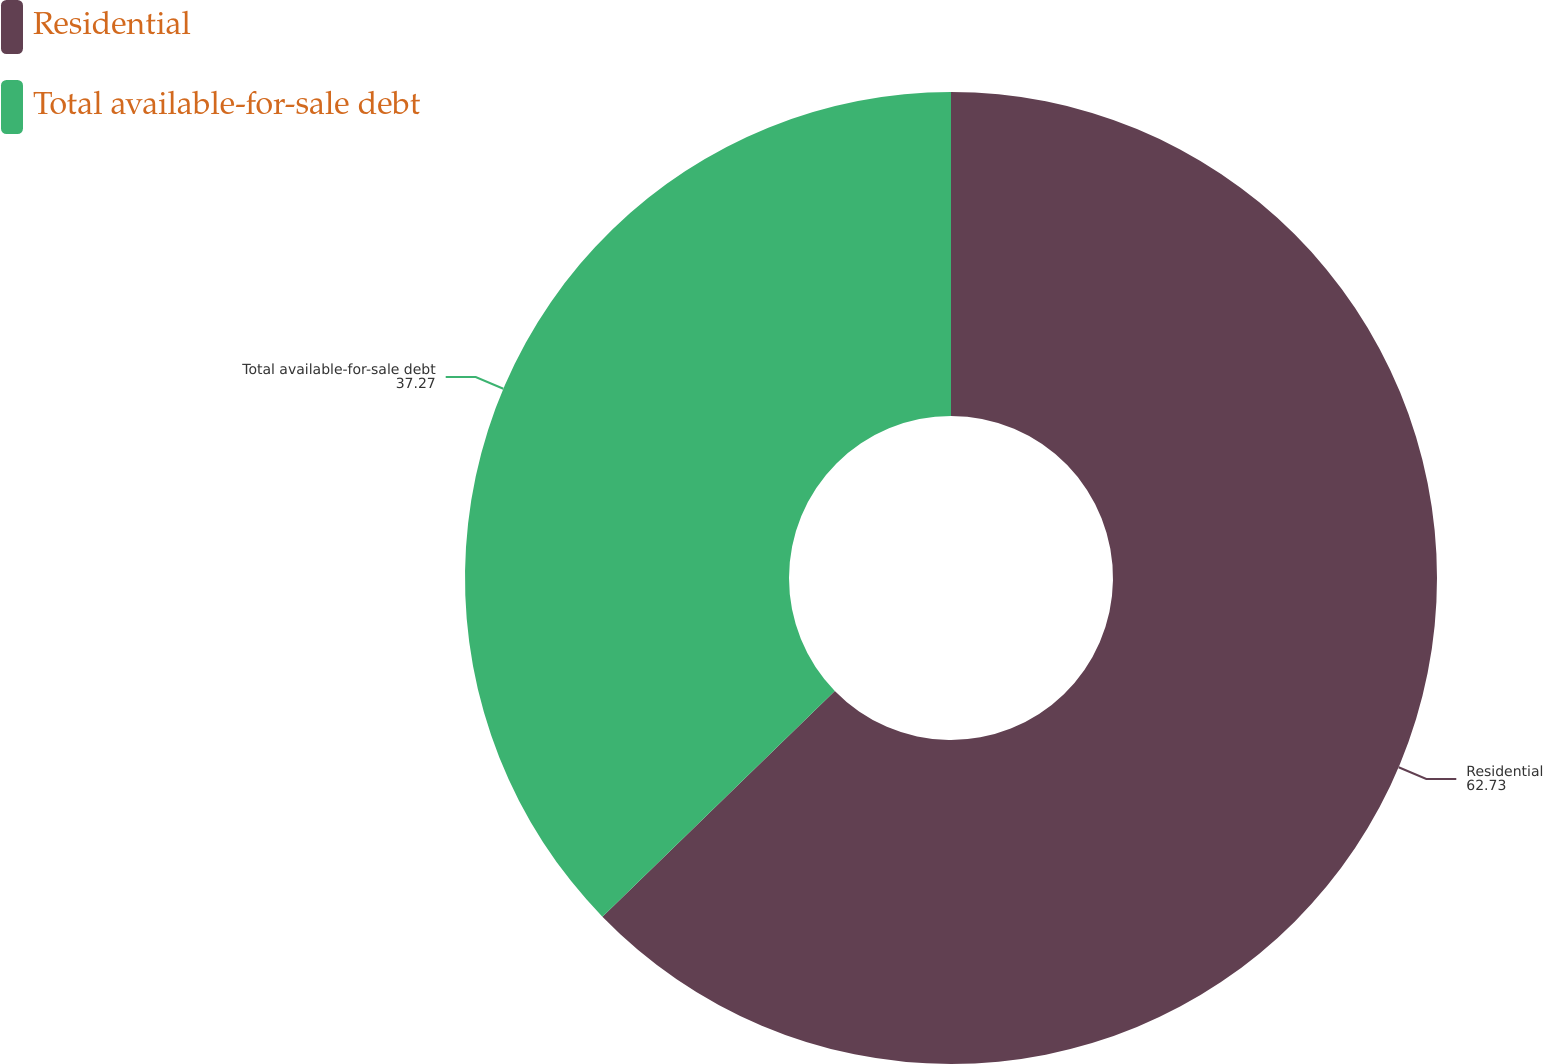Convert chart to OTSL. <chart><loc_0><loc_0><loc_500><loc_500><pie_chart><fcel>Residential<fcel>Total available-for-sale debt<nl><fcel>62.73%<fcel>37.27%<nl></chart> 